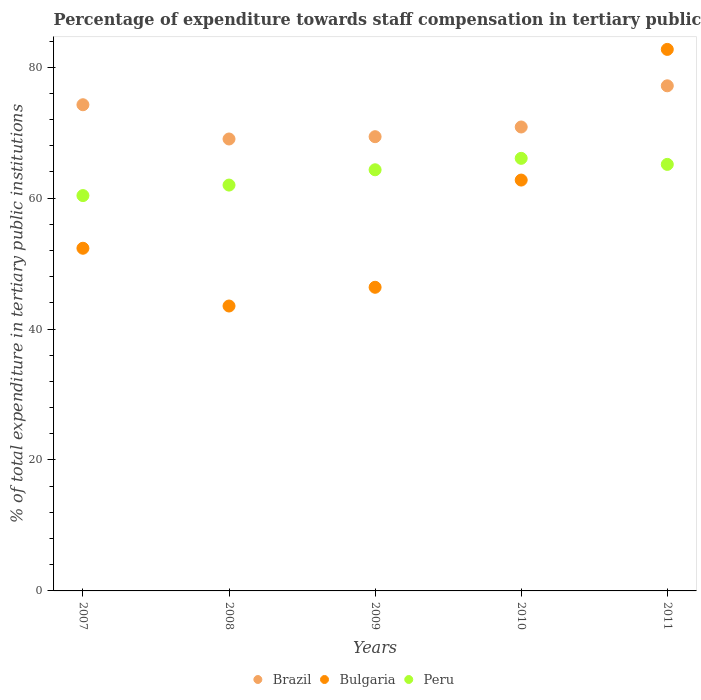How many different coloured dotlines are there?
Your answer should be very brief. 3. Is the number of dotlines equal to the number of legend labels?
Provide a short and direct response. Yes. What is the percentage of expenditure towards staff compensation in Peru in 2009?
Keep it short and to the point. 64.33. Across all years, what is the maximum percentage of expenditure towards staff compensation in Peru?
Ensure brevity in your answer.  66.08. Across all years, what is the minimum percentage of expenditure towards staff compensation in Bulgaria?
Provide a short and direct response. 43.52. What is the total percentage of expenditure towards staff compensation in Brazil in the graph?
Offer a terse response. 360.71. What is the difference between the percentage of expenditure towards staff compensation in Brazil in 2008 and that in 2009?
Keep it short and to the point. -0.35. What is the difference between the percentage of expenditure towards staff compensation in Brazil in 2011 and the percentage of expenditure towards staff compensation in Bulgaria in 2007?
Give a very brief answer. 24.81. What is the average percentage of expenditure towards staff compensation in Bulgaria per year?
Make the answer very short. 57.54. In the year 2007, what is the difference between the percentage of expenditure towards staff compensation in Bulgaria and percentage of expenditure towards staff compensation in Brazil?
Make the answer very short. -21.92. What is the ratio of the percentage of expenditure towards staff compensation in Brazil in 2010 to that in 2011?
Provide a succinct answer. 0.92. Is the percentage of expenditure towards staff compensation in Brazil in 2008 less than that in 2011?
Offer a very short reply. Yes. What is the difference between the highest and the second highest percentage of expenditure towards staff compensation in Bulgaria?
Your answer should be very brief. 19.96. What is the difference between the highest and the lowest percentage of expenditure towards staff compensation in Bulgaria?
Offer a very short reply. 39.2. In how many years, is the percentage of expenditure towards staff compensation in Brazil greater than the average percentage of expenditure towards staff compensation in Brazil taken over all years?
Offer a very short reply. 2. Is the sum of the percentage of expenditure towards staff compensation in Bulgaria in 2007 and 2011 greater than the maximum percentage of expenditure towards staff compensation in Peru across all years?
Your response must be concise. Yes. Is it the case that in every year, the sum of the percentage of expenditure towards staff compensation in Peru and percentage of expenditure towards staff compensation in Brazil  is greater than the percentage of expenditure towards staff compensation in Bulgaria?
Your answer should be compact. Yes. Is the percentage of expenditure towards staff compensation in Brazil strictly less than the percentage of expenditure towards staff compensation in Peru over the years?
Provide a short and direct response. No. How many dotlines are there?
Offer a very short reply. 3. How many years are there in the graph?
Your answer should be compact. 5. Does the graph contain grids?
Provide a succinct answer. No. Where does the legend appear in the graph?
Make the answer very short. Bottom center. How many legend labels are there?
Offer a very short reply. 3. How are the legend labels stacked?
Offer a very short reply. Horizontal. What is the title of the graph?
Ensure brevity in your answer.  Percentage of expenditure towards staff compensation in tertiary public institutions. Does "El Salvador" appear as one of the legend labels in the graph?
Keep it short and to the point. No. What is the label or title of the Y-axis?
Ensure brevity in your answer.  % of total expenditure in tertiary public institutions. What is the % of total expenditure in tertiary public institutions of Brazil in 2007?
Your response must be concise. 74.26. What is the % of total expenditure in tertiary public institutions of Bulgaria in 2007?
Your answer should be compact. 52.34. What is the % of total expenditure in tertiary public institutions of Peru in 2007?
Your answer should be very brief. 60.39. What is the % of total expenditure in tertiary public institutions of Brazil in 2008?
Offer a terse response. 69.03. What is the % of total expenditure in tertiary public institutions of Bulgaria in 2008?
Give a very brief answer. 43.52. What is the % of total expenditure in tertiary public institutions in Peru in 2008?
Offer a very short reply. 61.99. What is the % of total expenditure in tertiary public institutions in Brazil in 2009?
Make the answer very short. 69.39. What is the % of total expenditure in tertiary public institutions of Bulgaria in 2009?
Your answer should be very brief. 46.38. What is the % of total expenditure in tertiary public institutions of Peru in 2009?
Make the answer very short. 64.33. What is the % of total expenditure in tertiary public institutions in Brazil in 2010?
Provide a short and direct response. 70.87. What is the % of total expenditure in tertiary public institutions in Bulgaria in 2010?
Your answer should be compact. 62.76. What is the % of total expenditure in tertiary public institutions in Peru in 2010?
Make the answer very short. 66.08. What is the % of total expenditure in tertiary public institutions in Brazil in 2011?
Give a very brief answer. 77.16. What is the % of total expenditure in tertiary public institutions of Bulgaria in 2011?
Keep it short and to the point. 82.72. What is the % of total expenditure in tertiary public institutions of Peru in 2011?
Ensure brevity in your answer.  65.15. Across all years, what is the maximum % of total expenditure in tertiary public institutions of Brazil?
Your response must be concise. 77.16. Across all years, what is the maximum % of total expenditure in tertiary public institutions of Bulgaria?
Offer a terse response. 82.72. Across all years, what is the maximum % of total expenditure in tertiary public institutions in Peru?
Give a very brief answer. 66.08. Across all years, what is the minimum % of total expenditure in tertiary public institutions in Brazil?
Ensure brevity in your answer.  69.03. Across all years, what is the minimum % of total expenditure in tertiary public institutions of Bulgaria?
Provide a short and direct response. 43.52. Across all years, what is the minimum % of total expenditure in tertiary public institutions of Peru?
Your answer should be compact. 60.39. What is the total % of total expenditure in tertiary public institutions in Brazil in the graph?
Provide a short and direct response. 360.71. What is the total % of total expenditure in tertiary public institutions in Bulgaria in the graph?
Offer a very short reply. 287.72. What is the total % of total expenditure in tertiary public institutions in Peru in the graph?
Keep it short and to the point. 317.94. What is the difference between the % of total expenditure in tertiary public institutions in Brazil in 2007 and that in 2008?
Make the answer very short. 5.23. What is the difference between the % of total expenditure in tertiary public institutions of Bulgaria in 2007 and that in 2008?
Provide a succinct answer. 8.82. What is the difference between the % of total expenditure in tertiary public institutions in Peru in 2007 and that in 2008?
Keep it short and to the point. -1.61. What is the difference between the % of total expenditure in tertiary public institutions in Brazil in 2007 and that in 2009?
Give a very brief answer. 4.88. What is the difference between the % of total expenditure in tertiary public institutions in Bulgaria in 2007 and that in 2009?
Keep it short and to the point. 5.96. What is the difference between the % of total expenditure in tertiary public institutions in Peru in 2007 and that in 2009?
Your answer should be compact. -3.94. What is the difference between the % of total expenditure in tertiary public institutions in Brazil in 2007 and that in 2010?
Ensure brevity in your answer.  3.4. What is the difference between the % of total expenditure in tertiary public institutions in Bulgaria in 2007 and that in 2010?
Provide a succinct answer. -10.42. What is the difference between the % of total expenditure in tertiary public institutions in Peru in 2007 and that in 2010?
Ensure brevity in your answer.  -5.69. What is the difference between the % of total expenditure in tertiary public institutions in Brazil in 2007 and that in 2011?
Give a very brief answer. -2.89. What is the difference between the % of total expenditure in tertiary public institutions of Bulgaria in 2007 and that in 2011?
Give a very brief answer. -30.37. What is the difference between the % of total expenditure in tertiary public institutions in Peru in 2007 and that in 2011?
Your answer should be compact. -4.77. What is the difference between the % of total expenditure in tertiary public institutions of Brazil in 2008 and that in 2009?
Offer a terse response. -0.35. What is the difference between the % of total expenditure in tertiary public institutions of Bulgaria in 2008 and that in 2009?
Make the answer very short. -2.86. What is the difference between the % of total expenditure in tertiary public institutions of Peru in 2008 and that in 2009?
Give a very brief answer. -2.34. What is the difference between the % of total expenditure in tertiary public institutions of Brazil in 2008 and that in 2010?
Ensure brevity in your answer.  -1.83. What is the difference between the % of total expenditure in tertiary public institutions of Bulgaria in 2008 and that in 2010?
Provide a short and direct response. -19.24. What is the difference between the % of total expenditure in tertiary public institutions of Peru in 2008 and that in 2010?
Your response must be concise. -4.08. What is the difference between the % of total expenditure in tertiary public institutions in Brazil in 2008 and that in 2011?
Provide a succinct answer. -8.12. What is the difference between the % of total expenditure in tertiary public institutions in Bulgaria in 2008 and that in 2011?
Your answer should be very brief. -39.2. What is the difference between the % of total expenditure in tertiary public institutions in Peru in 2008 and that in 2011?
Make the answer very short. -3.16. What is the difference between the % of total expenditure in tertiary public institutions in Brazil in 2009 and that in 2010?
Make the answer very short. -1.48. What is the difference between the % of total expenditure in tertiary public institutions of Bulgaria in 2009 and that in 2010?
Make the answer very short. -16.38. What is the difference between the % of total expenditure in tertiary public institutions of Peru in 2009 and that in 2010?
Your response must be concise. -1.75. What is the difference between the % of total expenditure in tertiary public institutions in Brazil in 2009 and that in 2011?
Your answer should be very brief. -7.77. What is the difference between the % of total expenditure in tertiary public institutions of Bulgaria in 2009 and that in 2011?
Offer a very short reply. -36.34. What is the difference between the % of total expenditure in tertiary public institutions of Peru in 2009 and that in 2011?
Give a very brief answer. -0.82. What is the difference between the % of total expenditure in tertiary public institutions in Brazil in 2010 and that in 2011?
Offer a very short reply. -6.29. What is the difference between the % of total expenditure in tertiary public institutions in Bulgaria in 2010 and that in 2011?
Give a very brief answer. -19.96. What is the difference between the % of total expenditure in tertiary public institutions in Peru in 2010 and that in 2011?
Offer a terse response. 0.92. What is the difference between the % of total expenditure in tertiary public institutions of Brazil in 2007 and the % of total expenditure in tertiary public institutions of Bulgaria in 2008?
Your answer should be compact. 30.74. What is the difference between the % of total expenditure in tertiary public institutions of Brazil in 2007 and the % of total expenditure in tertiary public institutions of Peru in 2008?
Make the answer very short. 12.27. What is the difference between the % of total expenditure in tertiary public institutions in Bulgaria in 2007 and the % of total expenditure in tertiary public institutions in Peru in 2008?
Offer a very short reply. -9.65. What is the difference between the % of total expenditure in tertiary public institutions in Brazil in 2007 and the % of total expenditure in tertiary public institutions in Bulgaria in 2009?
Your answer should be very brief. 27.88. What is the difference between the % of total expenditure in tertiary public institutions in Brazil in 2007 and the % of total expenditure in tertiary public institutions in Peru in 2009?
Offer a terse response. 9.93. What is the difference between the % of total expenditure in tertiary public institutions of Bulgaria in 2007 and the % of total expenditure in tertiary public institutions of Peru in 2009?
Your answer should be very brief. -11.99. What is the difference between the % of total expenditure in tertiary public institutions in Brazil in 2007 and the % of total expenditure in tertiary public institutions in Bulgaria in 2010?
Keep it short and to the point. 11.51. What is the difference between the % of total expenditure in tertiary public institutions in Brazil in 2007 and the % of total expenditure in tertiary public institutions in Peru in 2010?
Provide a short and direct response. 8.19. What is the difference between the % of total expenditure in tertiary public institutions in Bulgaria in 2007 and the % of total expenditure in tertiary public institutions in Peru in 2010?
Make the answer very short. -13.73. What is the difference between the % of total expenditure in tertiary public institutions in Brazil in 2007 and the % of total expenditure in tertiary public institutions in Bulgaria in 2011?
Offer a very short reply. -8.45. What is the difference between the % of total expenditure in tertiary public institutions in Brazil in 2007 and the % of total expenditure in tertiary public institutions in Peru in 2011?
Provide a succinct answer. 9.11. What is the difference between the % of total expenditure in tertiary public institutions in Bulgaria in 2007 and the % of total expenditure in tertiary public institutions in Peru in 2011?
Your answer should be compact. -12.81. What is the difference between the % of total expenditure in tertiary public institutions in Brazil in 2008 and the % of total expenditure in tertiary public institutions in Bulgaria in 2009?
Keep it short and to the point. 22.65. What is the difference between the % of total expenditure in tertiary public institutions in Brazil in 2008 and the % of total expenditure in tertiary public institutions in Peru in 2009?
Your response must be concise. 4.7. What is the difference between the % of total expenditure in tertiary public institutions of Bulgaria in 2008 and the % of total expenditure in tertiary public institutions of Peru in 2009?
Offer a terse response. -20.81. What is the difference between the % of total expenditure in tertiary public institutions in Brazil in 2008 and the % of total expenditure in tertiary public institutions in Bulgaria in 2010?
Offer a terse response. 6.27. What is the difference between the % of total expenditure in tertiary public institutions of Brazil in 2008 and the % of total expenditure in tertiary public institutions of Peru in 2010?
Offer a very short reply. 2.96. What is the difference between the % of total expenditure in tertiary public institutions in Bulgaria in 2008 and the % of total expenditure in tertiary public institutions in Peru in 2010?
Offer a very short reply. -22.56. What is the difference between the % of total expenditure in tertiary public institutions of Brazil in 2008 and the % of total expenditure in tertiary public institutions of Bulgaria in 2011?
Your answer should be compact. -13.68. What is the difference between the % of total expenditure in tertiary public institutions of Brazil in 2008 and the % of total expenditure in tertiary public institutions of Peru in 2011?
Provide a short and direct response. 3.88. What is the difference between the % of total expenditure in tertiary public institutions of Bulgaria in 2008 and the % of total expenditure in tertiary public institutions of Peru in 2011?
Ensure brevity in your answer.  -21.63. What is the difference between the % of total expenditure in tertiary public institutions in Brazil in 2009 and the % of total expenditure in tertiary public institutions in Bulgaria in 2010?
Your answer should be compact. 6.63. What is the difference between the % of total expenditure in tertiary public institutions of Brazil in 2009 and the % of total expenditure in tertiary public institutions of Peru in 2010?
Your answer should be very brief. 3.31. What is the difference between the % of total expenditure in tertiary public institutions of Bulgaria in 2009 and the % of total expenditure in tertiary public institutions of Peru in 2010?
Give a very brief answer. -19.7. What is the difference between the % of total expenditure in tertiary public institutions of Brazil in 2009 and the % of total expenditure in tertiary public institutions of Bulgaria in 2011?
Your response must be concise. -13.33. What is the difference between the % of total expenditure in tertiary public institutions in Brazil in 2009 and the % of total expenditure in tertiary public institutions in Peru in 2011?
Make the answer very short. 4.23. What is the difference between the % of total expenditure in tertiary public institutions of Bulgaria in 2009 and the % of total expenditure in tertiary public institutions of Peru in 2011?
Ensure brevity in your answer.  -18.77. What is the difference between the % of total expenditure in tertiary public institutions in Brazil in 2010 and the % of total expenditure in tertiary public institutions in Bulgaria in 2011?
Make the answer very short. -11.85. What is the difference between the % of total expenditure in tertiary public institutions of Brazil in 2010 and the % of total expenditure in tertiary public institutions of Peru in 2011?
Make the answer very short. 5.71. What is the difference between the % of total expenditure in tertiary public institutions of Bulgaria in 2010 and the % of total expenditure in tertiary public institutions of Peru in 2011?
Ensure brevity in your answer.  -2.39. What is the average % of total expenditure in tertiary public institutions of Brazil per year?
Offer a terse response. 72.14. What is the average % of total expenditure in tertiary public institutions of Bulgaria per year?
Provide a succinct answer. 57.54. What is the average % of total expenditure in tertiary public institutions of Peru per year?
Offer a terse response. 63.59. In the year 2007, what is the difference between the % of total expenditure in tertiary public institutions in Brazil and % of total expenditure in tertiary public institutions in Bulgaria?
Your answer should be compact. 21.92. In the year 2007, what is the difference between the % of total expenditure in tertiary public institutions in Brazil and % of total expenditure in tertiary public institutions in Peru?
Ensure brevity in your answer.  13.88. In the year 2007, what is the difference between the % of total expenditure in tertiary public institutions of Bulgaria and % of total expenditure in tertiary public institutions of Peru?
Keep it short and to the point. -8.04. In the year 2008, what is the difference between the % of total expenditure in tertiary public institutions in Brazil and % of total expenditure in tertiary public institutions in Bulgaria?
Your answer should be very brief. 25.51. In the year 2008, what is the difference between the % of total expenditure in tertiary public institutions in Brazil and % of total expenditure in tertiary public institutions in Peru?
Make the answer very short. 7.04. In the year 2008, what is the difference between the % of total expenditure in tertiary public institutions of Bulgaria and % of total expenditure in tertiary public institutions of Peru?
Keep it short and to the point. -18.47. In the year 2009, what is the difference between the % of total expenditure in tertiary public institutions of Brazil and % of total expenditure in tertiary public institutions of Bulgaria?
Provide a short and direct response. 23. In the year 2009, what is the difference between the % of total expenditure in tertiary public institutions in Brazil and % of total expenditure in tertiary public institutions in Peru?
Provide a short and direct response. 5.05. In the year 2009, what is the difference between the % of total expenditure in tertiary public institutions of Bulgaria and % of total expenditure in tertiary public institutions of Peru?
Your answer should be very brief. -17.95. In the year 2010, what is the difference between the % of total expenditure in tertiary public institutions in Brazil and % of total expenditure in tertiary public institutions in Bulgaria?
Your response must be concise. 8.11. In the year 2010, what is the difference between the % of total expenditure in tertiary public institutions in Brazil and % of total expenditure in tertiary public institutions in Peru?
Your answer should be compact. 4.79. In the year 2010, what is the difference between the % of total expenditure in tertiary public institutions in Bulgaria and % of total expenditure in tertiary public institutions in Peru?
Offer a very short reply. -3.32. In the year 2011, what is the difference between the % of total expenditure in tertiary public institutions of Brazil and % of total expenditure in tertiary public institutions of Bulgaria?
Keep it short and to the point. -5.56. In the year 2011, what is the difference between the % of total expenditure in tertiary public institutions in Brazil and % of total expenditure in tertiary public institutions in Peru?
Keep it short and to the point. 12. In the year 2011, what is the difference between the % of total expenditure in tertiary public institutions in Bulgaria and % of total expenditure in tertiary public institutions in Peru?
Your answer should be very brief. 17.56. What is the ratio of the % of total expenditure in tertiary public institutions of Brazil in 2007 to that in 2008?
Keep it short and to the point. 1.08. What is the ratio of the % of total expenditure in tertiary public institutions of Bulgaria in 2007 to that in 2008?
Your answer should be compact. 1.2. What is the ratio of the % of total expenditure in tertiary public institutions in Peru in 2007 to that in 2008?
Your response must be concise. 0.97. What is the ratio of the % of total expenditure in tertiary public institutions of Brazil in 2007 to that in 2009?
Offer a terse response. 1.07. What is the ratio of the % of total expenditure in tertiary public institutions of Bulgaria in 2007 to that in 2009?
Your answer should be compact. 1.13. What is the ratio of the % of total expenditure in tertiary public institutions in Peru in 2007 to that in 2009?
Offer a very short reply. 0.94. What is the ratio of the % of total expenditure in tertiary public institutions of Brazil in 2007 to that in 2010?
Ensure brevity in your answer.  1.05. What is the ratio of the % of total expenditure in tertiary public institutions of Bulgaria in 2007 to that in 2010?
Offer a terse response. 0.83. What is the ratio of the % of total expenditure in tertiary public institutions of Peru in 2007 to that in 2010?
Give a very brief answer. 0.91. What is the ratio of the % of total expenditure in tertiary public institutions of Brazil in 2007 to that in 2011?
Ensure brevity in your answer.  0.96. What is the ratio of the % of total expenditure in tertiary public institutions of Bulgaria in 2007 to that in 2011?
Give a very brief answer. 0.63. What is the ratio of the % of total expenditure in tertiary public institutions of Peru in 2007 to that in 2011?
Your answer should be compact. 0.93. What is the ratio of the % of total expenditure in tertiary public institutions of Bulgaria in 2008 to that in 2009?
Provide a short and direct response. 0.94. What is the ratio of the % of total expenditure in tertiary public institutions of Peru in 2008 to that in 2009?
Your answer should be very brief. 0.96. What is the ratio of the % of total expenditure in tertiary public institutions in Brazil in 2008 to that in 2010?
Provide a short and direct response. 0.97. What is the ratio of the % of total expenditure in tertiary public institutions in Bulgaria in 2008 to that in 2010?
Give a very brief answer. 0.69. What is the ratio of the % of total expenditure in tertiary public institutions in Peru in 2008 to that in 2010?
Your answer should be compact. 0.94. What is the ratio of the % of total expenditure in tertiary public institutions in Brazil in 2008 to that in 2011?
Provide a succinct answer. 0.89. What is the ratio of the % of total expenditure in tertiary public institutions of Bulgaria in 2008 to that in 2011?
Make the answer very short. 0.53. What is the ratio of the % of total expenditure in tertiary public institutions of Peru in 2008 to that in 2011?
Your answer should be very brief. 0.95. What is the ratio of the % of total expenditure in tertiary public institutions of Brazil in 2009 to that in 2010?
Provide a succinct answer. 0.98. What is the ratio of the % of total expenditure in tertiary public institutions in Bulgaria in 2009 to that in 2010?
Offer a terse response. 0.74. What is the ratio of the % of total expenditure in tertiary public institutions of Peru in 2009 to that in 2010?
Give a very brief answer. 0.97. What is the ratio of the % of total expenditure in tertiary public institutions of Brazil in 2009 to that in 2011?
Your response must be concise. 0.9. What is the ratio of the % of total expenditure in tertiary public institutions of Bulgaria in 2009 to that in 2011?
Provide a succinct answer. 0.56. What is the ratio of the % of total expenditure in tertiary public institutions of Peru in 2009 to that in 2011?
Offer a terse response. 0.99. What is the ratio of the % of total expenditure in tertiary public institutions of Brazil in 2010 to that in 2011?
Your response must be concise. 0.92. What is the ratio of the % of total expenditure in tertiary public institutions in Bulgaria in 2010 to that in 2011?
Provide a short and direct response. 0.76. What is the ratio of the % of total expenditure in tertiary public institutions of Peru in 2010 to that in 2011?
Give a very brief answer. 1.01. What is the difference between the highest and the second highest % of total expenditure in tertiary public institutions of Brazil?
Make the answer very short. 2.89. What is the difference between the highest and the second highest % of total expenditure in tertiary public institutions of Bulgaria?
Keep it short and to the point. 19.96. What is the difference between the highest and the second highest % of total expenditure in tertiary public institutions in Peru?
Give a very brief answer. 0.92. What is the difference between the highest and the lowest % of total expenditure in tertiary public institutions of Brazil?
Your answer should be very brief. 8.12. What is the difference between the highest and the lowest % of total expenditure in tertiary public institutions in Bulgaria?
Provide a succinct answer. 39.2. What is the difference between the highest and the lowest % of total expenditure in tertiary public institutions of Peru?
Make the answer very short. 5.69. 